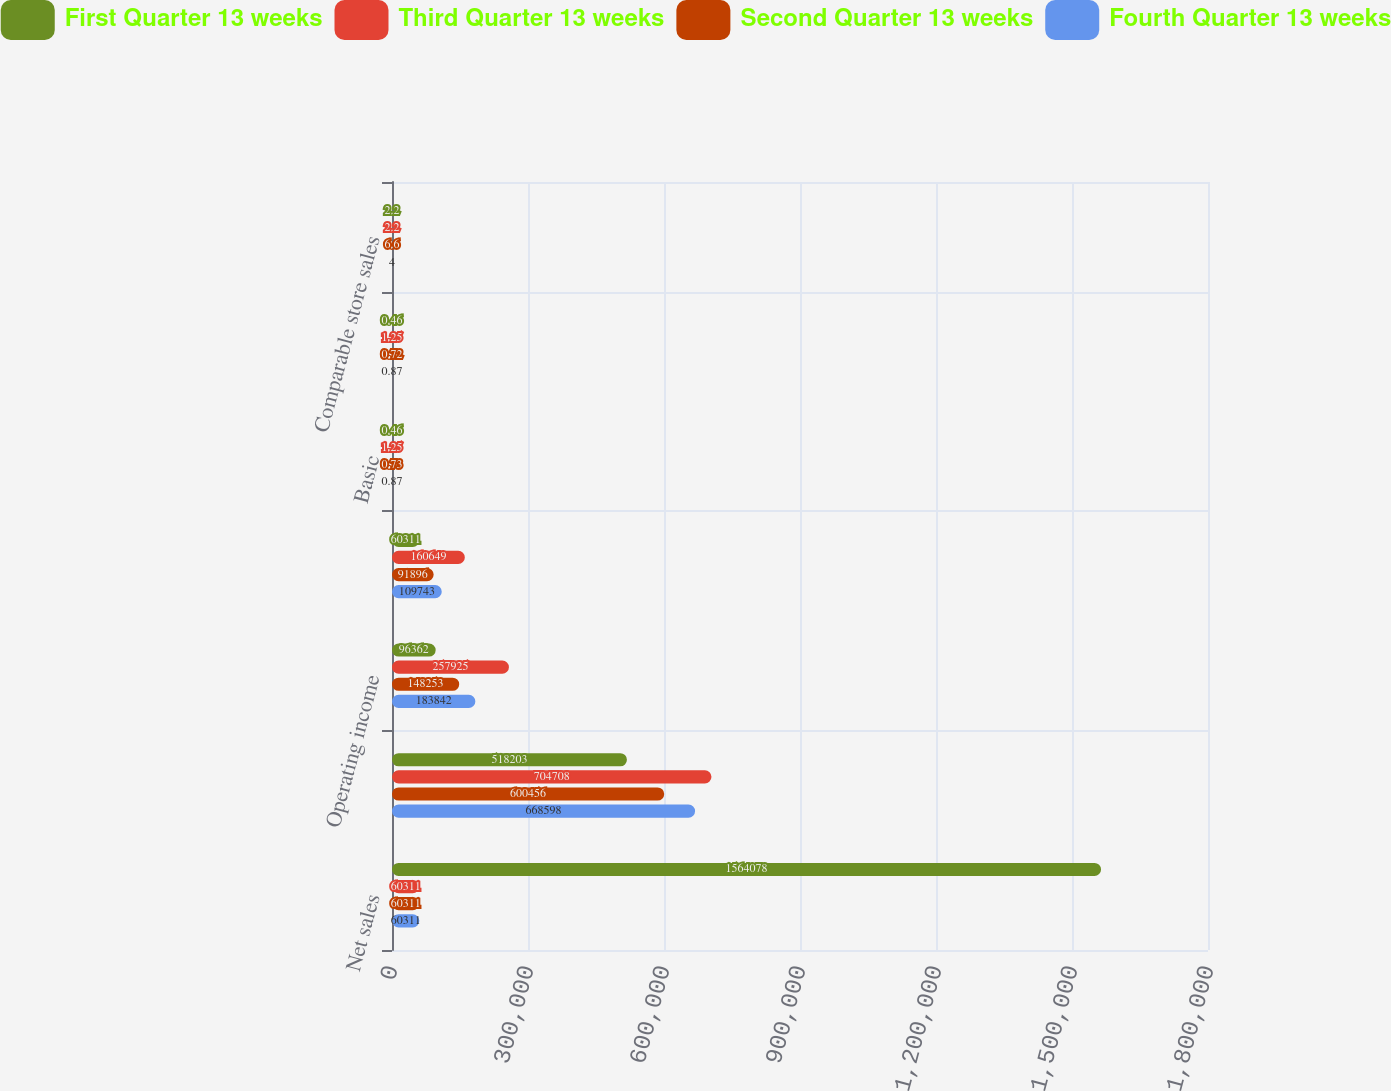Convert chart to OTSL. <chart><loc_0><loc_0><loc_500><loc_500><stacked_bar_chart><ecel><fcel>Net sales<fcel>Gross profit<fcel>Operating income<fcel>Net income<fcel>Basic<fcel>Diluted<fcel>Comparable store sales<nl><fcel>First Quarter 13 weeks<fcel>1.56408e+06<fcel>518203<fcel>96362<fcel>60311<fcel>0.46<fcel>0.46<fcel>2.2<nl><fcel>Third Quarter 13 weeks<fcel>60311<fcel>704708<fcel>257925<fcel>160649<fcel>1.25<fcel>1.25<fcel>2.2<nl><fcel>Second Quarter 13 weeks<fcel>60311<fcel>600456<fcel>148253<fcel>91896<fcel>0.73<fcel>0.72<fcel>6.6<nl><fcel>Fourth Quarter 13 weeks<fcel>60311<fcel>668598<fcel>183842<fcel>109743<fcel>0.87<fcel>0.87<fcel>4<nl></chart> 